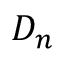Convert formula to latex. <formula><loc_0><loc_0><loc_500><loc_500>D _ { n }</formula> 